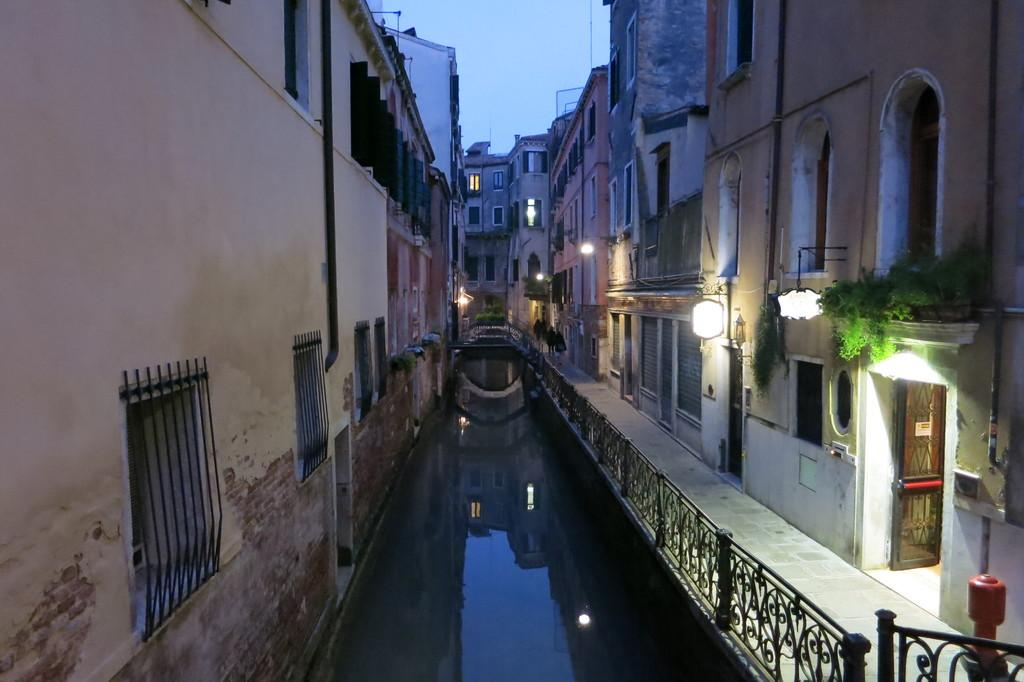What is the primary element present in the image? There is water in the image. What type of structures can be seen in the image? There are buildings in the image. What feature of the buildings is visible in the image? There are windows visible in the image. What type of barrier is present in the image? There is a fence in the image. What is visible at the top of the image? The sky is visible at the top of the image. What type of disease is affecting the tomatoes in the image? There are no tomatoes present in the image, so it is not possible to determine if there is any disease affecting them. 